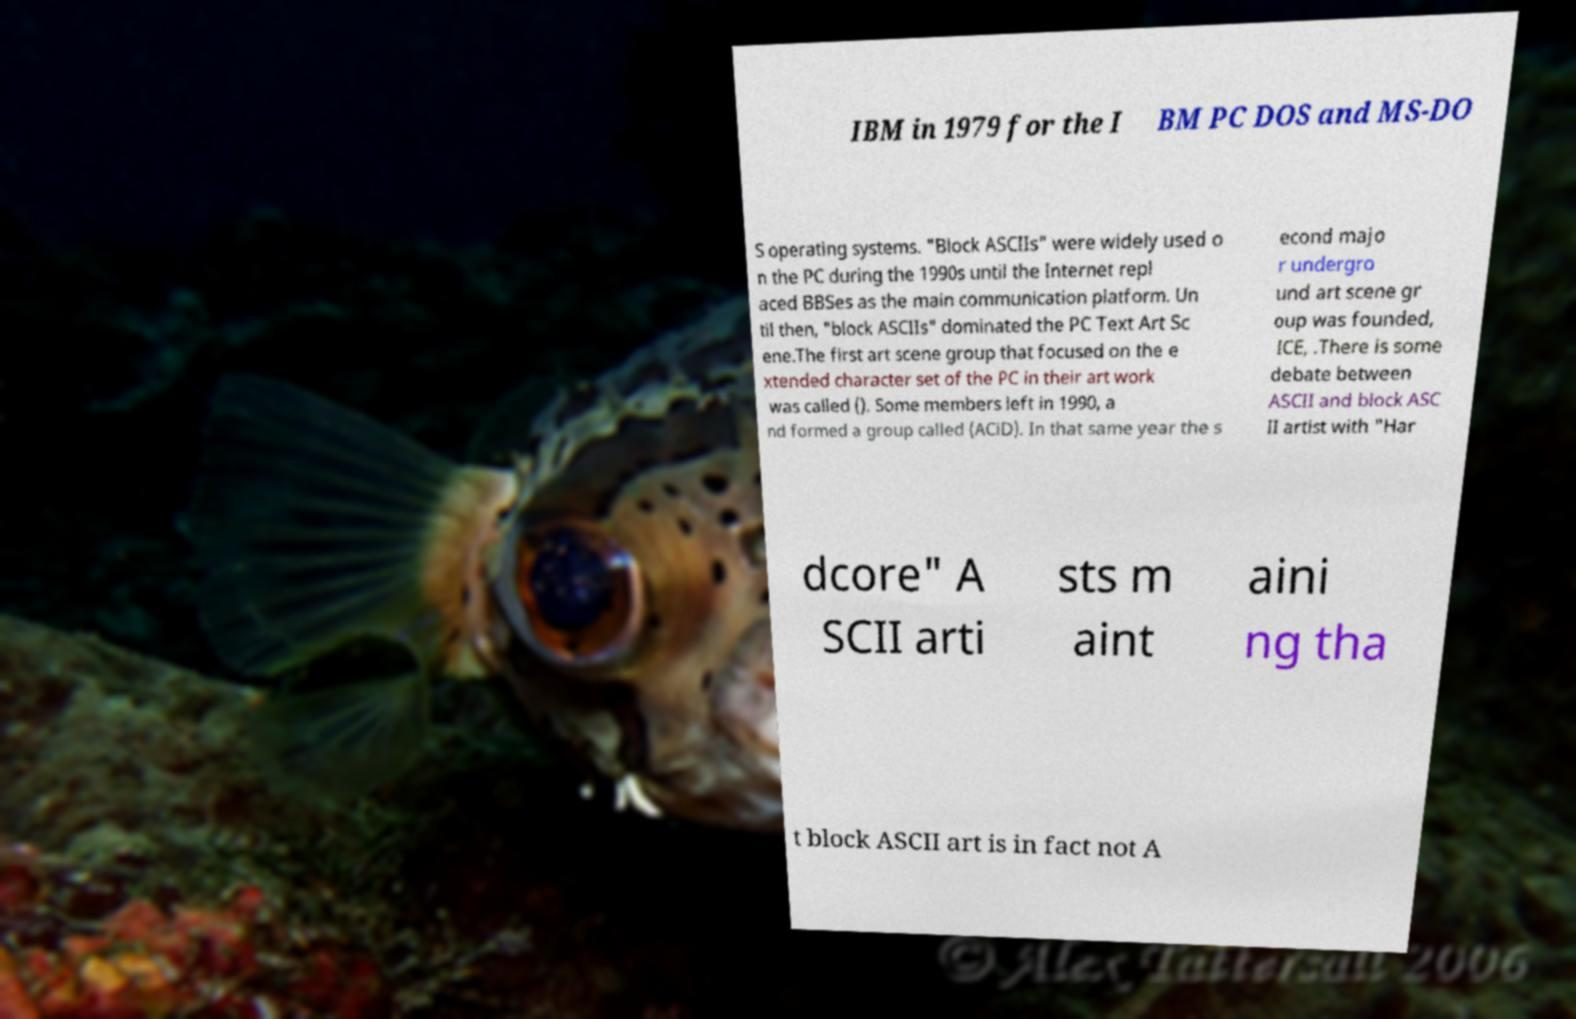I need the written content from this picture converted into text. Can you do that? IBM in 1979 for the I BM PC DOS and MS-DO S operating systems. "Block ASCIIs" were widely used o n the PC during the 1990s until the Internet repl aced BBSes as the main communication platform. Un til then, "block ASCIIs" dominated the PC Text Art Sc ene.The first art scene group that focused on the e xtended character set of the PC in their art work was called (). Some members left in 1990, a nd formed a group called (ACiD). In that same year the s econd majo r undergro und art scene gr oup was founded, ICE, .There is some debate between ASCII and block ASC II artist with "Har dcore" A SCII arti sts m aint aini ng tha t block ASCII art is in fact not A 